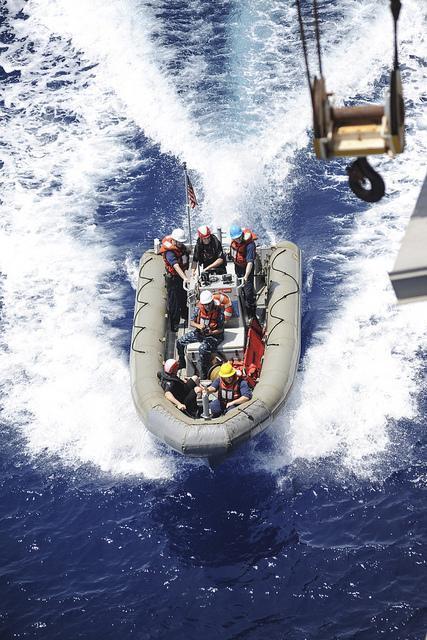How many people are there?
Give a very brief answer. 2. How many elephants are there?
Give a very brief answer. 0. 